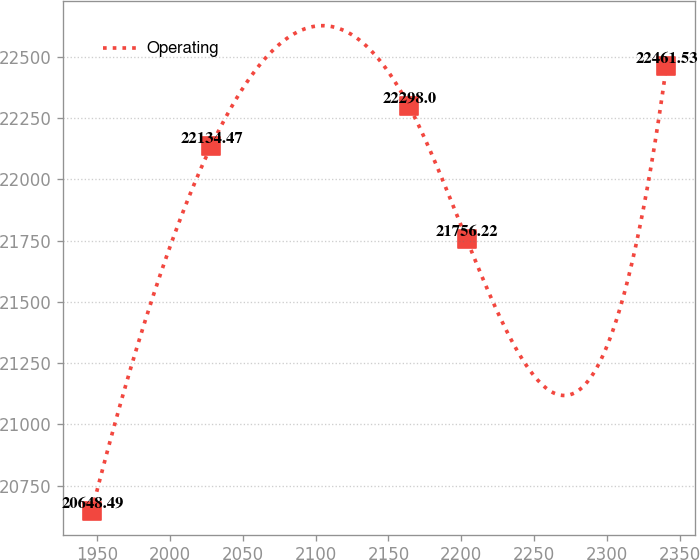Convert chart. <chart><loc_0><loc_0><loc_500><loc_500><line_chart><ecel><fcel>Operating<nl><fcel>1946.58<fcel>20648.5<nl><fcel>2028.31<fcel>22134.5<nl><fcel>2164.16<fcel>22298<nl><fcel>2203.57<fcel>21756.2<nl><fcel>2340.66<fcel>22461.5<nl></chart> 